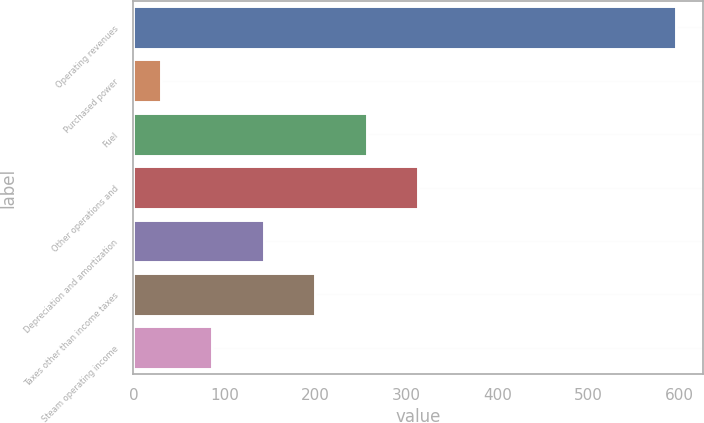<chart> <loc_0><loc_0><loc_500><loc_500><bar_chart><fcel>Operating revenues<fcel>Purchased power<fcel>Fuel<fcel>Other operations and<fcel>Depreciation and amortization<fcel>Taxes other than income taxes<fcel>Steam operating income<nl><fcel>596<fcel>30<fcel>256.4<fcel>313<fcel>143.2<fcel>199.8<fcel>86.6<nl></chart> 